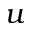Convert formula to latex. <formula><loc_0><loc_0><loc_500><loc_500>u</formula> 